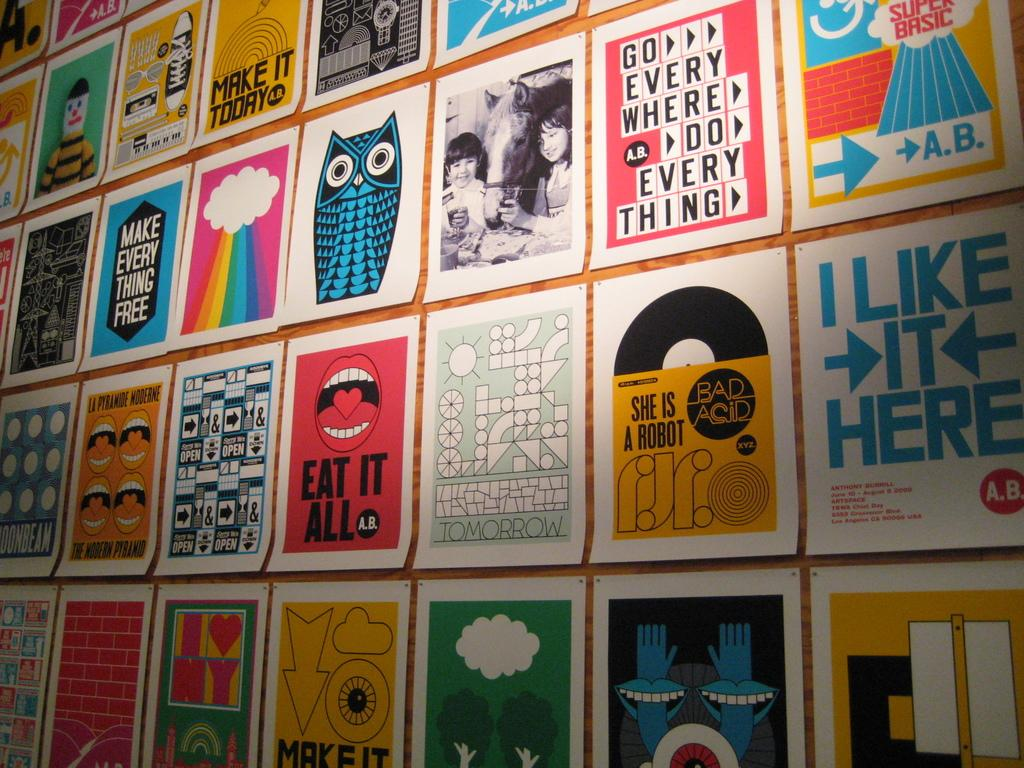Provide a one-sentence caption for the provided image. A bunch of posters are lined up together, including an owl and a mouth that says "EAT IT ALL". 